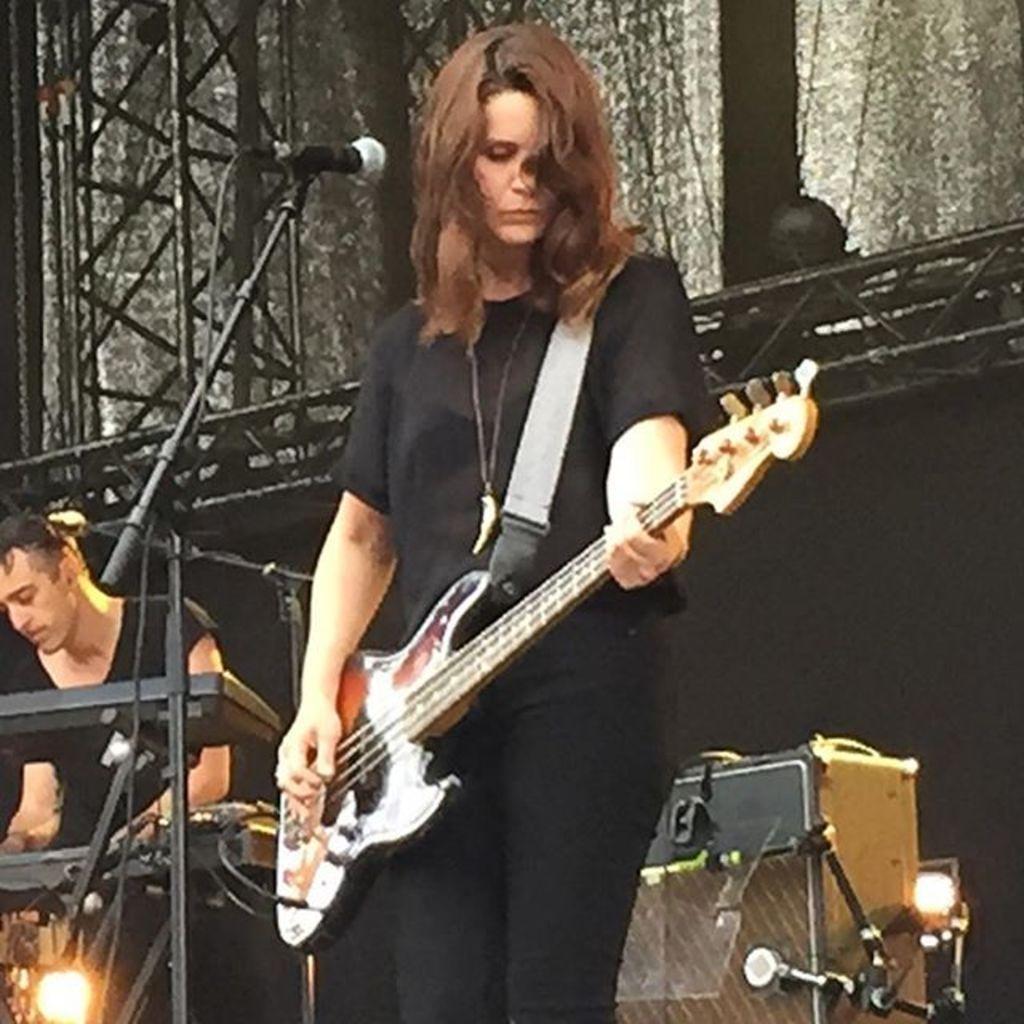How would you summarize this image in a sentence or two? As we can see in the image there are two people wearing black color dresses. The woman over here is holding a guitar. There is a mic, curtains and musical keyboard. 